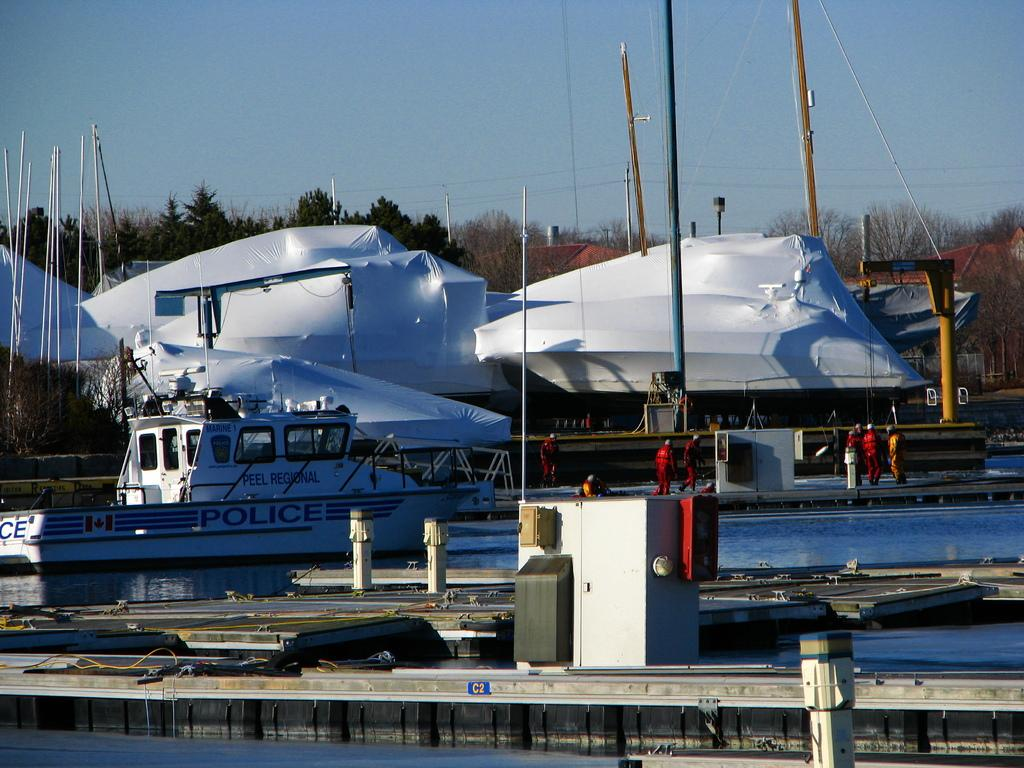<image>
Summarize the visual content of the image. A police boat is tied up near some large, covered boats that are out of the water. 